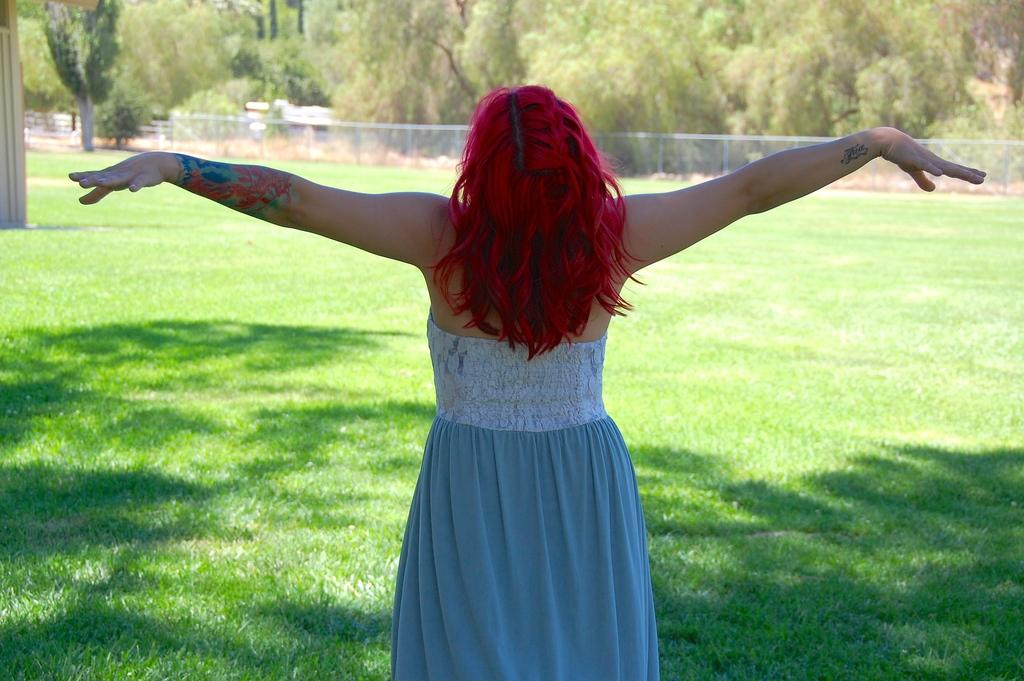What is the main subject of the image? There is a person standing in the image. What type of terrain is visible in the image? There is grass visible in the image. What can be seen in the background of the image? There are trees in the background of the image. What color is the guide's middle moon in the image? There is no guide or moon present in the image. 